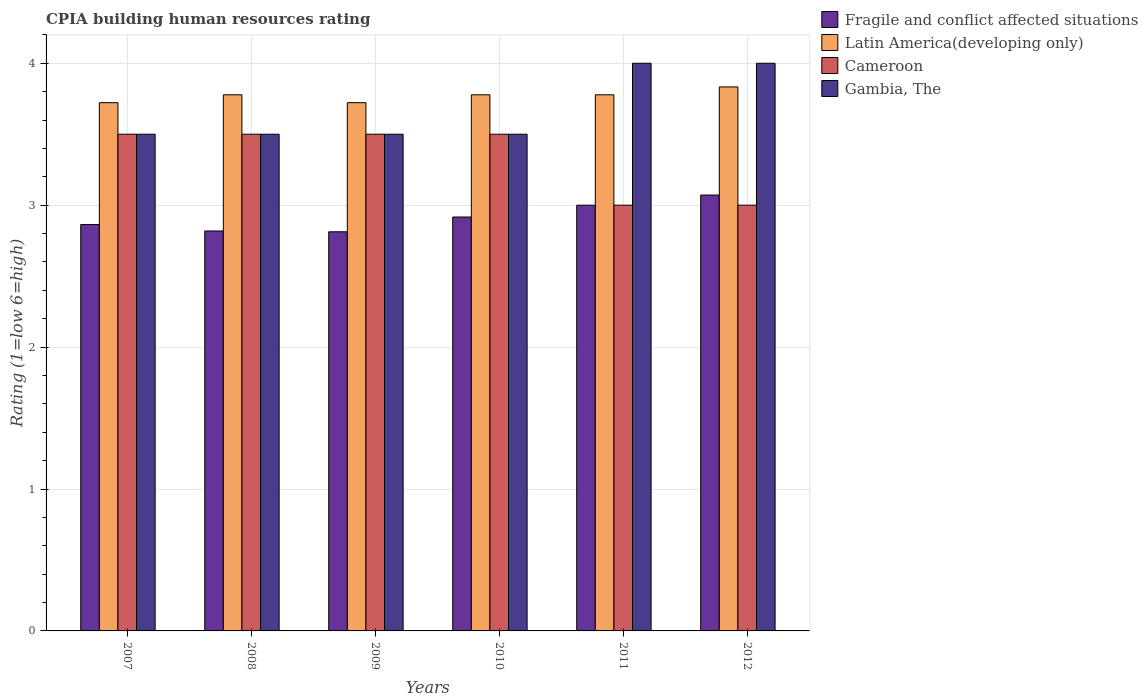How many groups of bars are there?
Provide a succinct answer. 6. Are the number of bars per tick equal to the number of legend labels?
Provide a succinct answer. Yes. What is the label of the 4th group of bars from the left?
Provide a short and direct response. 2010. In how many cases, is the number of bars for a given year not equal to the number of legend labels?
Provide a succinct answer. 0. What is the CPIA rating in Latin America(developing only) in 2007?
Provide a short and direct response. 3.72. Across all years, what is the maximum CPIA rating in Latin America(developing only)?
Provide a short and direct response. 3.83. Across all years, what is the minimum CPIA rating in Latin America(developing only)?
Your response must be concise. 3.72. What is the total CPIA rating in Cameroon in the graph?
Give a very brief answer. 20. What is the difference between the CPIA rating in Fragile and conflict affected situations in 2008 and that in 2012?
Your answer should be compact. -0.25. What is the difference between the CPIA rating in Latin America(developing only) in 2011 and the CPIA rating in Fragile and conflict affected situations in 2010?
Ensure brevity in your answer.  0.86. What is the average CPIA rating in Latin America(developing only) per year?
Your answer should be very brief. 3.77. In the year 2011, what is the difference between the CPIA rating in Gambia, The and CPIA rating in Cameroon?
Provide a short and direct response. 1. In how many years, is the CPIA rating in Latin America(developing only) greater than 0.6000000000000001?
Your answer should be compact. 6. What is the ratio of the CPIA rating in Cameroon in 2008 to that in 2010?
Make the answer very short. 1. Is the difference between the CPIA rating in Gambia, The in 2010 and 2012 greater than the difference between the CPIA rating in Cameroon in 2010 and 2012?
Make the answer very short. No. What is the difference between the highest and the lowest CPIA rating in Cameroon?
Offer a very short reply. 0.5. Is the sum of the CPIA rating in Cameroon in 2009 and 2010 greater than the maximum CPIA rating in Latin America(developing only) across all years?
Provide a short and direct response. Yes. What does the 3rd bar from the left in 2007 represents?
Your answer should be very brief. Cameroon. What does the 1st bar from the right in 2012 represents?
Make the answer very short. Gambia, The. How many bars are there?
Your answer should be compact. 24. Are all the bars in the graph horizontal?
Keep it short and to the point. No. What is the difference between two consecutive major ticks on the Y-axis?
Ensure brevity in your answer.  1. Are the values on the major ticks of Y-axis written in scientific E-notation?
Offer a very short reply. No. Does the graph contain any zero values?
Your answer should be very brief. No. What is the title of the graph?
Ensure brevity in your answer.  CPIA building human resources rating. What is the label or title of the X-axis?
Offer a very short reply. Years. What is the Rating (1=low 6=high) in Fragile and conflict affected situations in 2007?
Keep it short and to the point. 2.86. What is the Rating (1=low 6=high) in Latin America(developing only) in 2007?
Your response must be concise. 3.72. What is the Rating (1=low 6=high) of Fragile and conflict affected situations in 2008?
Offer a very short reply. 2.82. What is the Rating (1=low 6=high) in Latin America(developing only) in 2008?
Your response must be concise. 3.78. What is the Rating (1=low 6=high) in Cameroon in 2008?
Your answer should be compact. 3.5. What is the Rating (1=low 6=high) in Gambia, The in 2008?
Provide a short and direct response. 3.5. What is the Rating (1=low 6=high) of Fragile and conflict affected situations in 2009?
Offer a terse response. 2.81. What is the Rating (1=low 6=high) of Latin America(developing only) in 2009?
Provide a succinct answer. 3.72. What is the Rating (1=low 6=high) of Gambia, The in 2009?
Offer a very short reply. 3.5. What is the Rating (1=low 6=high) in Fragile and conflict affected situations in 2010?
Your response must be concise. 2.92. What is the Rating (1=low 6=high) in Latin America(developing only) in 2010?
Provide a short and direct response. 3.78. What is the Rating (1=low 6=high) of Fragile and conflict affected situations in 2011?
Keep it short and to the point. 3. What is the Rating (1=low 6=high) in Latin America(developing only) in 2011?
Offer a very short reply. 3.78. What is the Rating (1=low 6=high) in Fragile and conflict affected situations in 2012?
Your answer should be very brief. 3.07. What is the Rating (1=low 6=high) in Latin America(developing only) in 2012?
Offer a very short reply. 3.83. What is the Rating (1=low 6=high) in Cameroon in 2012?
Make the answer very short. 3. Across all years, what is the maximum Rating (1=low 6=high) of Fragile and conflict affected situations?
Your response must be concise. 3.07. Across all years, what is the maximum Rating (1=low 6=high) in Latin America(developing only)?
Offer a very short reply. 3.83. Across all years, what is the maximum Rating (1=low 6=high) in Gambia, The?
Keep it short and to the point. 4. Across all years, what is the minimum Rating (1=low 6=high) in Fragile and conflict affected situations?
Your answer should be compact. 2.81. Across all years, what is the minimum Rating (1=low 6=high) of Latin America(developing only)?
Offer a terse response. 3.72. Across all years, what is the minimum Rating (1=low 6=high) of Gambia, The?
Your answer should be very brief. 3.5. What is the total Rating (1=low 6=high) of Fragile and conflict affected situations in the graph?
Provide a short and direct response. 17.48. What is the total Rating (1=low 6=high) in Latin America(developing only) in the graph?
Offer a terse response. 22.61. What is the total Rating (1=low 6=high) in Cameroon in the graph?
Give a very brief answer. 20. What is the total Rating (1=low 6=high) of Gambia, The in the graph?
Your answer should be very brief. 22. What is the difference between the Rating (1=low 6=high) of Fragile and conflict affected situations in 2007 and that in 2008?
Ensure brevity in your answer.  0.05. What is the difference between the Rating (1=low 6=high) of Latin America(developing only) in 2007 and that in 2008?
Ensure brevity in your answer.  -0.06. What is the difference between the Rating (1=low 6=high) in Gambia, The in 2007 and that in 2008?
Your answer should be compact. 0. What is the difference between the Rating (1=low 6=high) of Fragile and conflict affected situations in 2007 and that in 2009?
Offer a very short reply. 0.05. What is the difference between the Rating (1=low 6=high) of Latin America(developing only) in 2007 and that in 2009?
Provide a succinct answer. 0. What is the difference between the Rating (1=low 6=high) in Cameroon in 2007 and that in 2009?
Offer a terse response. 0. What is the difference between the Rating (1=low 6=high) of Fragile and conflict affected situations in 2007 and that in 2010?
Offer a terse response. -0.05. What is the difference between the Rating (1=low 6=high) in Latin America(developing only) in 2007 and that in 2010?
Give a very brief answer. -0.06. What is the difference between the Rating (1=low 6=high) in Fragile and conflict affected situations in 2007 and that in 2011?
Provide a succinct answer. -0.14. What is the difference between the Rating (1=low 6=high) in Latin America(developing only) in 2007 and that in 2011?
Offer a very short reply. -0.06. What is the difference between the Rating (1=low 6=high) of Gambia, The in 2007 and that in 2011?
Keep it short and to the point. -0.5. What is the difference between the Rating (1=low 6=high) of Fragile and conflict affected situations in 2007 and that in 2012?
Give a very brief answer. -0.21. What is the difference between the Rating (1=low 6=high) of Latin America(developing only) in 2007 and that in 2012?
Offer a terse response. -0.11. What is the difference between the Rating (1=low 6=high) of Gambia, The in 2007 and that in 2012?
Your answer should be compact. -0.5. What is the difference between the Rating (1=low 6=high) in Fragile and conflict affected situations in 2008 and that in 2009?
Your answer should be very brief. 0.01. What is the difference between the Rating (1=low 6=high) of Latin America(developing only) in 2008 and that in 2009?
Offer a terse response. 0.06. What is the difference between the Rating (1=low 6=high) of Gambia, The in 2008 and that in 2009?
Your response must be concise. 0. What is the difference between the Rating (1=low 6=high) of Fragile and conflict affected situations in 2008 and that in 2010?
Offer a terse response. -0.1. What is the difference between the Rating (1=low 6=high) of Gambia, The in 2008 and that in 2010?
Your answer should be compact. 0. What is the difference between the Rating (1=low 6=high) of Fragile and conflict affected situations in 2008 and that in 2011?
Offer a terse response. -0.18. What is the difference between the Rating (1=low 6=high) in Latin America(developing only) in 2008 and that in 2011?
Keep it short and to the point. 0. What is the difference between the Rating (1=low 6=high) of Cameroon in 2008 and that in 2011?
Keep it short and to the point. 0.5. What is the difference between the Rating (1=low 6=high) of Gambia, The in 2008 and that in 2011?
Keep it short and to the point. -0.5. What is the difference between the Rating (1=low 6=high) of Fragile and conflict affected situations in 2008 and that in 2012?
Keep it short and to the point. -0.25. What is the difference between the Rating (1=low 6=high) in Latin America(developing only) in 2008 and that in 2012?
Give a very brief answer. -0.06. What is the difference between the Rating (1=low 6=high) in Cameroon in 2008 and that in 2012?
Your answer should be compact. 0.5. What is the difference between the Rating (1=low 6=high) of Gambia, The in 2008 and that in 2012?
Give a very brief answer. -0.5. What is the difference between the Rating (1=low 6=high) of Fragile and conflict affected situations in 2009 and that in 2010?
Give a very brief answer. -0.1. What is the difference between the Rating (1=low 6=high) in Latin America(developing only) in 2009 and that in 2010?
Your response must be concise. -0.06. What is the difference between the Rating (1=low 6=high) in Cameroon in 2009 and that in 2010?
Provide a short and direct response. 0. What is the difference between the Rating (1=low 6=high) of Fragile and conflict affected situations in 2009 and that in 2011?
Your response must be concise. -0.19. What is the difference between the Rating (1=low 6=high) in Latin America(developing only) in 2009 and that in 2011?
Provide a short and direct response. -0.06. What is the difference between the Rating (1=low 6=high) in Gambia, The in 2009 and that in 2011?
Keep it short and to the point. -0.5. What is the difference between the Rating (1=low 6=high) of Fragile and conflict affected situations in 2009 and that in 2012?
Your response must be concise. -0.26. What is the difference between the Rating (1=low 6=high) in Latin America(developing only) in 2009 and that in 2012?
Offer a terse response. -0.11. What is the difference between the Rating (1=low 6=high) of Gambia, The in 2009 and that in 2012?
Provide a succinct answer. -0.5. What is the difference between the Rating (1=low 6=high) in Fragile and conflict affected situations in 2010 and that in 2011?
Your answer should be compact. -0.08. What is the difference between the Rating (1=low 6=high) in Latin America(developing only) in 2010 and that in 2011?
Give a very brief answer. 0. What is the difference between the Rating (1=low 6=high) of Cameroon in 2010 and that in 2011?
Offer a terse response. 0.5. What is the difference between the Rating (1=low 6=high) in Fragile and conflict affected situations in 2010 and that in 2012?
Your answer should be compact. -0.15. What is the difference between the Rating (1=low 6=high) in Latin America(developing only) in 2010 and that in 2012?
Your response must be concise. -0.06. What is the difference between the Rating (1=low 6=high) of Cameroon in 2010 and that in 2012?
Offer a terse response. 0.5. What is the difference between the Rating (1=low 6=high) in Fragile and conflict affected situations in 2011 and that in 2012?
Give a very brief answer. -0.07. What is the difference between the Rating (1=low 6=high) in Latin America(developing only) in 2011 and that in 2012?
Ensure brevity in your answer.  -0.06. What is the difference between the Rating (1=low 6=high) of Cameroon in 2011 and that in 2012?
Your answer should be very brief. 0. What is the difference between the Rating (1=low 6=high) in Fragile and conflict affected situations in 2007 and the Rating (1=low 6=high) in Latin America(developing only) in 2008?
Provide a short and direct response. -0.91. What is the difference between the Rating (1=low 6=high) in Fragile and conflict affected situations in 2007 and the Rating (1=low 6=high) in Cameroon in 2008?
Provide a short and direct response. -0.64. What is the difference between the Rating (1=low 6=high) in Fragile and conflict affected situations in 2007 and the Rating (1=low 6=high) in Gambia, The in 2008?
Offer a terse response. -0.64. What is the difference between the Rating (1=low 6=high) of Latin America(developing only) in 2007 and the Rating (1=low 6=high) of Cameroon in 2008?
Your answer should be very brief. 0.22. What is the difference between the Rating (1=low 6=high) of Latin America(developing only) in 2007 and the Rating (1=low 6=high) of Gambia, The in 2008?
Provide a short and direct response. 0.22. What is the difference between the Rating (1=low 6=high) in Cameroon in 2007 and the Rating (1=low 6=high) in Gambia, The in 2008?
Your answer should be compact. 0. What is the difference between the Rating (1=low 6=high) of Fragile and conflict affected situations in 2007 and the Rating (1=low 6=high) of Latin America(developing only) in 2009?
Give a very brief answer. -0.86. What is the difference between the Rating (1=low 6=high) of Fragile and conflict affected situations in 2007 and the Rating (1=low 6=high) of Cameroon in 2009?
Provide a short and direct response. -0.64. What is the difference between the Rating (1=low 6=high) in Fragile and conflict affected situations in 2007 and the Rating (1=low 6=high) in Gambia, The in 2009?
Your answer should be very brief. -0.64. What is the difference between the Rating (1=low 6=high) in Latin America(developing only) in 2007 and the Rating (1=low 6=high) in Cameroon in 2009?
Offer a very short reply. 0.22. What is the difference between the Rating (1=low 6=high) in Latin America(developing only) in 2007 and the Rating (1=low 6=high) in Gambia, The in 2009?
Provide a succinct answer. 0.22. What is the difference between the Rating (1=low 6=high) in Cameroon in 2007 and the Rating (1=low 6=high) in Gambia, The in 2009?
Keep it short and to the point. 0. What is the difference between the Rating (1=low 6=high) of Fragile and conflict affected situations in 2007 and the Rating (1=low 6=high) of Latin America(developing only) in 2010?
Ensure brevity in your answer.  -0.91. What is the difference between the Rating (1=low 6=high) of Fragile and conflict affected situations in 2007 and the Rating (1=low 6=high) of Cameroon in 2010?
Provide a succinct answer. -0.64. What is the difference between the Rating (1=low 6=high) of Fragile and conflict affected situations in 2007 and the Rating (1=low 6=high) of Gambia, The in 2010?
Offer a terse response. -0.64. What is the difference between the Rating (1=low 6=high) in Latin America(developing only) in 2007 and the Rating (1=low 6=high) in Cameroon in 2010?
Provide a short and direct response. 0.22. What is the difference between the Rating (1=low 6=high) of Latin America(developing only) in 2007 and the Rating (1=low 6=high) of Gambia, The in 2010?
Keep it short and to the point. 0.22. What is the difference between the Rating (1=low 6=high) in Fragile and conflict affected situations in 2007 and the Rating (1=low 6=high) in Latin America(developing only) in 2011?
Provide a succinct answer. -0.91. What is the difference between the Rating (1=low 6=high) in Fragile and conflict affected situations in 2007 and the Rating (1=low 6=high) in Cameroon in 2011?
Provide a succinct answer. -0.14. What is the difference between the Rating (1=low 6=high) of Fragile and conflict affected situations in 2007 and the Rating (1=low 6=high) of Gambia, The in 2011?
Offer a very short reply. -1.14. What is the difference between the Rating (1=low 6=high) of Latin America(developing only) in 2007 and the Rating (1=low 6=high) of Cameroon in 2011?
Your answer should be compact. 0.72. What is the difference between the Rating (1=low 6=high) of Latin America(developing only) in 2007 and the Rating (1=low 6=high) of Gambia, The in 2011?
Offer a terse response. -0.28. What is the difference between the Rating (1=low 6=high) in Fragile and conflict affected situations in 2007 and the Rating (1=low 6=high) in Latin America(developing only) in 2012?
Your response must be concise. -0.97. What is the difference between the Rating (1=low 6=high) in Fragile and conflict affected situations in 2007 and the Rating (1=low 6=high) in Cameroon in 2012?
Offer a very short reply. -0.14. What is the difference between the Rating (1=low 6=high) of Fragile and conflict affected situations in 2007 and the Rating (1=low 6=high) of Gambia, The in 2012?
Offer a terse response. -1.14. What is the difference between the Rating (1=low 6=high) in Latin America(developing only) in 2007 and the Rating (1=low 6=high) in Cameroon in 2012?
Your response must be concise. 0.72. What is the difference between the Rating (1=low 6=high) in Latin America(developing only) in 2007 and the Rating (1=low 6=high) in Gambia, The in 2012?
Your response must be concise. -0.28. What is the difference between the Rating (1=low 6=high) in Cameroon in 2007 and the Rating (1=low 6=high) in Gambia, The in 2012?
Provide a succinct answer. -0.5. What is the difference between the Rating (1=low 6=high) in Fragile and conflict affected situations in 2008 and the Rating (1=low 6=high) in Latin America(developing only) in 2009?
Your answer should be compact. -0.9. What is the difference between the Rating (1=low 6=high) of Fragile and conflict affected situations in 2008 and the Rating (1=low 6=high) of Cameroon in 2009?
Your answer should be very brief. -0.68. What is the difference between the Rating (1=low 6=high) of Fragile and conflict affected situations in 2008 and the Rating (1=low 6=high) of Gambia, The in 2009?
Your answer should be very brief. -0.68. What is the difference between the Rating (1=low 6=high) of Latin America(developing only) in 2008 and the Rating (1=low 6=high) of Cameroon in 2009?
Your answer should be very brief. 0.28. What is the difference between the Rating (1=low 6=high) in Latin America(developing only) in 2008 and the Rating (1=low 6=high) in Gambia, The in 2009?
Offer a terse response. 0.28. What is the difference between the Rating (1=low 6=high) of Fragile and conflict affected situations in 2008 and the Rating (1=low 6=high) of Latin America(developing only) in 2010?
Keep it short and to the point. -0.96. What is the difference between the Rating (1=low 6=high) of Fragile and conflict affected situations in 2008 and the Rating (1=low 6=high) of Cameroon in 2010?
Ensure brevity in your answer.  -0.68. What is the difference between the Rating (1=low 6=high) in Fragile and conflict affected situations in 2008 and the Rating (1=low 6=high) in Gambia, The in 2010?
Offer a terse response. -0.68. What is the difference between the Rating (1=low 6=high) of Latin America(developing only) in 2008 and the Rating (1=low 6=high) of Cameroon in 2010?
Provide a succinct answer. 0.28. What is the difference between the Rating (1=low 6=high) of Latin America(developing only) in 2008 and the Rating (1=low 6=high) of Gambia, The in 2010?
Keep it short and to the point. 0.28. What is the difference between the Rating (1=low 6=high) of Cameroon in 2008 and the Rating (1=low 6=high) of Gambia, The in 2010?
Make the answer very short. 0. What is the difference between the Rating (1=low 6=high) of Fragile and conflict affected situations in 2008 and the Rating (1=low 6=high) of Latin America(developing only) in 2011?
Offer a terse response. -0.96. What is the difference between the Rating (1=low 6=high) of Fragile and conflict affected situations in 2008 and the Rating (1=low 6=high) of Cameroon in 2011?
Offer a very short reply. -0.18. What is the difference between the Rating (1=low 6=high) of Fragile and conflict affected situations in 2008 and the Rating (1=low 6=high) of Gambia, The in 2011?
Give a very brief answer. -1.18. What is the difference between the Rating (1=low 6=high) in Latin America(developing only) in 2008 and the Rating (1=low 6=high) in Gambia, The in 2011?
Give a very brief answer. -0.22. What is the difference between the Rating (1=low 6=high) of Fragile and conflict affected situations in 2008 and the Rating (1=low 6=high) of Latin America(developing only) in 2012?
Make the answer very short. -1.02. What is the difference between the Rating (1=low 6=high) of Fragile and conflict affected situations in 2008 and the Rating (1=low 6=high) of Cameroon in 2012?
Ensure brevity in your answer.  -0.18. What is the difference between the Rating (1=low 6=high) of Fragile and conflict affected situations in 2008 and the Rating (1=low 6=high) of Gambia, The in 2012?
Give a very brief answer. -1.18. What is the difference between the Rating (1=low 6=high) of Latin America(developing only) in 2008 and the Rating (1=low 6=high) of Cameroon in 2012?
Make the answer very short. 0.78. What is the difference between the Rating (1=low 6=high) in Latin America(developing only) in 2008 and the Rating (1=low 6=high) in Gambia, The in 2012?
Give a very brief answer. -0.22. What is the difference between the Rating (1=low 6=high) of Fragile and conflict affected situations in 2009 and the Rating (1=low 6=high) of Latin America(developing only) in 2010?
Provide a short and direct response. -0.97. What is the difference between the Rating (1=low 6=high) of Fragile and conflict affected situations in 2009 and the Rating (1=low 6=high) of Cameroon in 2010?
Your response must be concise. -0.69. What is the difference between the Rating (1=low 6=high) in Fragile and conflict affected situations in 2009 and the Rating (1=low 6=high) in Gambia, The in 2010?
Your answer should be very brief. -0.69. What is the difference between the Rating (1=low 6=high) in Latin America(developing only) in 2009 and the Rating (1=low 6=high) in Cameroon in 2010?
Your answer should be compact. 0.22. What is the difference between the Rating (1=low 6=high) of Latin America(developing only) in 2009 and the Rating (1=low 6=high) of Gambia, The in 2010?
Your answer should be very brief. 0.22. What is the difference between the Rating (1=low 6=high) in Cameroon in 2009 and the Rating (1=low 6=high) in Gambia, The in 2010?
Offer a terse response. 0. What is the difference between the Rating (1=low 6=high) in Fragile and conflict affected situations in 2009 and the Rating (1=low 6=high) in Latin America(developing only) in 2011?
Your answer should be very brief. -0.97. What is the difference between the Rating (1=low 6=high) of Fragile and conflict affected situations in 2009 and the Rating (1=low 6=high) of Cameroon in 2011?
Offer a very short reply. -0.19. What is the difference between the Rating (1=low 6=high) of Fragile and conflict affected situations in 2009 and the Rating (1=low 6=high) of Gambia, The in 2011?
Offer a terse response. -1.19. What is the difference between the Rating (1=low 6=high) of Latin America(developing only) in 2009 and the Rating (1=low 6=high) of Cameroon in 2011?
Offer a very short reply. 0.72. What is the difference between the Rating (1=low 6=high) in Latin America(developing only) in 2009 and the Rating (1=low 6=high) in Gambia, The in 2011?
Your answer should be compact. -0.28. What is the difference between the Rating (1=low 6=high) of Cameroon in 2009 and the Rating (1=low 6=high) of Gambia, The in 2011?
Offer a terse response. -0.5. What is the difference between the Rating (1=low 6=high) of Fragile and conflict affected situations in 2009 and the Rating (1=low 6=high) of Latin America(developing only) in 2012?
Ensure brevity in your answer.  -1.02. What is the difference between the Rating (1=low 6=high) in Fragile and conflict affected situations in 2009 and the Rating (1=low 6=high) in Cameroon in 2012?
Provide a short and direct response. -0.19. What is the difference between the Rating (1=low 6=high) of Fragile and conflict affected situations in 2009 and the Rating (1=low 6=high) of Gambia, The in 2012?
Make the answer very short. -1.19. What is the difference between the Rating (1=low 6=high) of Latin America(developing only) in 2009 and the Rating (1=low 6=high) of Cameroon in 2012?
Your answer should be compact. 0.72. What is the difference between the Rating (1=low 6=high) in Latin America(developing only) in 2009 and the Rating (1=low 6=high) in Gambia, The in 2012?
Ensure brevity in your answer.  -0.28. What is the difference between the Rating (1=low 6=high) in Fragile and conflict affected situations in 2010 and the Rating (1=low 6=high) in Latin America(developing only) in 2011?
Your answer should be very brief. -0.86. What is the difference between the Rating (1=low 6=high) in Fragile and conflict affected situations in 2010 and the Rating (1=low 6=high) in Cameroon in 2011?
Provide a succinct answer. -0.08. What is the difference between the Rating (1=low 6=high) in Fragile and conflict affected situations in 2010 and the Rating (1=low 6=high) in Gambia, The in 2011?
Offer a very short reply. -1.08. What is the difference between the Rating (1=low 6=high) in Latin America(developing only) in 2010 and the Rating (1=low 6=high) in Cameroon in 2011?
Offer a very short reply. 0.78. What is the difference between the Rating (1=low 6=high) in Latin America(developing only) in 2010 and the Rating (1=low 6=high) in Gambia, The in 2011?
Ensure brevity in your answer.  -0.22. What is the difference between the Rating (1=low 6=high) of Cameroon in 2010 and the Rating (1=low 6=high) of Gambia, The in 2011?
Provide a short and direct response. -0.5. What is the difference between the Rating (1=low 6=high) of Fragile and conflict affected situations in 2010 and the Rating (1=low 6=high) of Latin America(developing only) in 2012?
Your response must be concise. -0.92. What is the difference between the Rating (1=low 6=high) in Fragile and conflict affected situations in 2010 and the Rating (1=low 6=high) in Cameroon in 2012?
Your answer should be very brief. -0.08. What is the difference between the Rating (1=low 6=high) of Fragile and conflict affected situations in 2010 and the Rating (1=low 6=high) of Gambia, The in 2012?
Your response must be concise. -1.08. What is the difference between the Rating (1=low 6=high) of Latin America(developing only) in 2010 and the Rating (1=low 6=high) of Cameroon in 2012?
Your answer should be very brief. 0.78. What is the difference between the Rating (1=low 6=high) in Latin America(developing only) in 2010 and the Rating (1=low 6=high) in Gambia, The in 2012?
Ensure brevity in your answer.  -0.22. What is the difference between the Rating (1=low 6=high) in Fragile and conflict affected situations in 2011 and the Rating (1=low 6=high) in Latin America(developing only) in 2012?
Keep it short and to the point. -0.83. What is the difference between the Rating (1=low 6=high) in Fragile and conflict affected situations in 2011 and the Rating (1=low 6=high) in Cameroon in 2012?
Ensure brevity in your answer.  0. What is the difference between the Rating (1=low 6=high) of Fragile and conflict affected situations in 2011 and the Rating (1=low 6=high) of Gambia, The in 2012?
Ensure brevity in your answer.  -1. What is the difference between the Rating (1=low 6=high) of Latin America(developing only) in 2011 and the Rating (1=low 6=high) of Cameroon in 2012?
Your response must be concise. 0.78. What is the difference between the Rating (1=low 6=high) in Latin America(developing only) in 2011 and the Rating (1=low 6=high) in Gambia, The in 2012?
Provide a short and direct response. -0.22. What is the average Rating (1=low 6=high) of Fragile and conflict affected situations per year?
Make the answer very short. 2.91. What is the average Rating (1=low 6=high) of Latin America(developing only) per year?
Your answer should be very brief. 3.77. What is the average Rating (1=low 6=high) of Cameroon per year?
Provide a succinct answer. 3.33. What is the average Rating (1=low 6=high) of Gambia, The per year?
Make the answer very short. 3.67. In the year 2007, what is the difference between the Rating (1=low 6=high) in Fragile and conflict affected situations and Rating (1=low 6=high) in Latin America(developing only)?
Keep it short and to the point. -0.86. In the year 2007, what is the difference between the Rating (1=low 6=high) of Fragile and conflict affected situations and Rating (1=low 6=high) of Cameroon?
Provide a succinct answer. -0.64. In the year 2007, what is the difference between the Rating (1=low 6=high) of Fragile and conflict affected situations and Rating (1=low 6=high) of Gambia, The?
Your answer should be compact. -0.64. In the year 2007, what is the difference between the Rating (1=low 6=high) in Latin America(developing only) and Rating (1=low 6=high) in Cameroon?
Provide a succinct answer. 0.22. In the year 2007, what is the difference between the Rating (1=low 6=high) in Latin America(developing only) and Rating (1=low 6=high) in Gambia, The?
Your response must be concise. 0.22. In the year 2007, what is the difference between the Rating (1=low 6=high) in Cameroon and Rating (1=low 6=high) in Gambia, The?
Your answer should be compact. 0. In the year 2008, what is the difference between the Rating (1=low 6=high) in Fragile and conflict affected situations and Rating (1=low 6=high) in Latin America(developing only)?
Make the answer very short. -0.96. In the year 2008, what is the difference between the Rating (1=low 6=high) in Fragile and conflict affected situations and Rating (1=low 6=high) in Cameroon?
Offer a very short reply. -0.68. In the year 2008, what is the difference between the Rating (1=low 6=high) in Fragile and conflict affected situations and Rating (1=low 6=high) in Gambia, The?
Your answer should be compact. -0.68. In the year 2008, what is the difference between the Rating (1=low 6=high) in Latin America(developing only) and Rating (1=low 6=high) in Cameroon?
Offer a very short reply. 0.28. In the year 2008, what is the difference between the Rating (1=low 6=high) in Latin America(developing only) and Rating (1=low 6=high) in Gambia, The?
Keep it short and to the point. 0.28. In the year 2008, what is the difference between the Rating (1=low 6=high) of Cameroon and Rating (1=low 6=high) of Gambia, The?
Your answer should be compact. 0. In the year 2009, what is the difference between the Rating (1=low 6=high) in Fragile and conflict affected situations and Rating (1=low 6=high) in Latin America(developing only)?
Your response must be concise. -0.91. In the year 2009, what is the difference between the Rating (1=low 6=high) of Fragile and conflict affected situations and Rating (1=low 6=high) of Cameroon?
Ensure brevity in your answer.  -0.69. In the year 2009, what is the difference between the Rating (1=low 6=high) in Fragile and conflict affected situations and Rating (1=low 6=high) in Gambia, The?
Your response must be concise. -0.69. In the year 2009, what is the difference between the Rating (1=low 6=high) of Latin America(developing only) and Rating (1=low 6=high) of Cameroon?
Your response must be concise. 0.22. In the year 2009, what is the difference between the Rating (1=low 6=high) of Latin America(developing only) and Rating (1=low 6=high) of Gambia, The?
Keep it short and to the point. 0.22. In the year 2010, what is the difference between the Rating (1=low 6=high) in Fragile and conflict affected situations and Rating (1=low 6=high) in Latin America(developing only)?
Provide a succinct answer. -0.86. In the year 2010, what is the difference between the Rating (1=low 6=high) in Fragile and conflict affected situations and Rating (1=low 6=high) in Cameroon?
Your response must be concise. -0.58. In the year 2010, what is the difference between the Rating (1=low 6=high) in Fragile and conflict affected situations and Rating (1=low 6=high) in Gambia, The?
Give a very brief answer. -0.58. In the year 2010, what is the difference between the Rating (1=low 6=high) of Latin America(developing only) and Rating (1=low 6=high) of Cameroon?
Give a very brief answer. 0.28. In the year 2010, what is the difference between the Rating (1=low 6=high) of Latin America(developing only) and Rating (1=low 6=high) of Gambia, The?
Your response must be concise. 0.28. In the year 2010, what is the difference between the Rating (1=low 6=high) in Cameroon and Rating (1=low 6=high) in Gambia, The?
Keep it short and to the point. 0. In the year 2011, what is the difference between the Rating (1=low 6=high) of Fragile and conflict affected situations and Rating (1=low 6=high) of Latin America(developing only)?
Offer a very short reply. -0.78. In the year 2011, what is the difference between the Rating (1=low 6=high) of Fragile and conflict affected situations and Rating (1=low 6=high) of Cameroon?
Give a very brief answer. 0. In the year 2011, what is the difference between the Rating (1=low 6=high) in Latin America(developing only) and Rating (1=low 6=high) in Gambia, The?
Make the answer very short. -0.22. In the year 2011, what is the difference between the Rating (1=low 6=high) in Cameroon and Rating (1=low 6=high) in Gambia, The?
Make the answer very short. -1. In the year 2012, what is the difference between the Rating (1=low 6=high) in Fragile and conflict affected situations and Rating (1=low 6=high) in Latin America(developing only)?
Your answer should be very brief. -0.76. In the year 2012, what is the difference between the Rating (1=low 6=high) of Fragile and conflict affected situations and Rating (1=low 6=high) of Cameroon?
Offer a very short reply. 0.07. In the year 2012, what is the difference between the Rating (1=low 6=high) of Fragile and conflict affected situations and Rating (1=low 6=high) of Gambia, The?
Your response must be concise. -0.93. In the year 2012, what is the difference between the Rating (1=low 6=high) of Latin America(developing only) and Rating (1=low 6=high) of Cameroon?
Your answer should be very brief. 0.83. In the year 2012, what is the difference between the Rating (1=low 6=high) in Latin America(developing only) and Rating (1=low 6=high) in Gambia, The?
Ensure brevity in your answer.  -0.17. In the year 2012, what is the difference between the Rating (1=low 6=high) of Cameroon and Rating (1=low 6=high) of Gambia, The?
Offer a terse response. -1. What is the ratio of the Rating (1=low 6=high) in Fragile and conflict affected situations in 2007 to that in 2008?
Give a very brief answer. 1.02. What is the ratio of the Rating (1=low 6=high) of Latin America(developing only) in 2007 to that in 2008?
Ensure brevity in your answer.  0.99. What is the ratio of the Rating (1=low 6=high) of Cameroon in 2007 to that in 2008?
Ensure brevity in your answer.  1. What is the ratio of the Rating (1=low 6=high) of Fragile and conflict affected situations in 2007 to that in 2009?
Your answer should be very brief. 1.02. What is the ratio of the Rating (1=low 6=high) of Latin America(developing only) in 2007 to that in 2009?
Offer a very short reply. 1. What is the ratio of the Rating (1=low 6=high) in Fragile and conflict affected situations in 2007 to that in 2010?
Keep it short and to the point. 0.98. What is the ratio of the Rating (1=low 6=high) in Fragile and conflict affected situations in 2007 to that in 2011?
Keep it short and to the point. 0.95. What is the ratio of the Rating (1=low 6=high) in Latin America(developing only) in 2007 to that in 2011?
Your response must be concise. 0.99. What is the ratio of the Rating (1=low 6=high) in Cameroon in 2007 to that in 2011?
Give a very brief answer. 1.17. What is the ratio of the Rating (1=low 6=high) of Fragile and conflict affected situations in 2007 to that in 2012?
Your answer should be very brief. 0.93. What is the ratio of the Rating (1=low 6=high) in Latin America(developing only) in 2007 to that in 2012?
Give a very brief answer. 0.97. What is the ratio of the Rating (1=low 6=high) in Fragile and conflict affected situations in 2008 to that in 2009?
Offer a terse response. 1. What is the ratio of the Rating (1=low 6=high) of Latin America(developing only) in 2008 to that in 2009?
Keep it short and to the point. 1.01. What is the ratio of the Rating (1=low 6=high) of Cameroon in 2008 to that in 2009?
Provide a succinct answer. 1. What is the ratio of the Rating (1=low 6=high) in Gambia, The in 2008 to that in 2009?
Provide a succinct answer. 1. What is the ratio of the Rating (1=low 6=high) of Fragile and conflict affected situations in 2008 to that in 2010?
Provide a succinct answer. 0.97. What is the ratio of the Rating (1=low 6=high) of Latin America(developing only) in 2008 to that in 2010?
Give a very brief answer. 1. What is the ratio of the Rating (1=low 6=high) of Gambia, The in 2008 to that in 2010?
Offer a terse response. 1. What is the ratio of the Rating (1=low 6=high) in Fragile and conflict affected situations in 2008 to that in 2011?
Offer a terse response. 0.94. What is the ratio of the Rating (1=low 6=high) in Latin America(developing only) in 2008 to that in 2011?
Your response must be concise. 1. What is the ratio of the Rating (1=low 6=high) of Cameroon in 2008 to that in 2011?
Your answer should be compact. 1.17. What is the ratio of the Rating (1=low 6=high) in Fragile and conflict affected situations in 2008 to that in 2012?
Give a very brief answer. 0.92. What is the ratio of the Rating (1=low 6=high) of Latin America(developing only) in 2008 to that in 2012?
Give a very brief answer. 0.99. What is the ratio of the Rating (1=low 6=high) in Cameroon in 2008 to that in 2012?
Offer a terse response. 1.17. What is the ratio of the Rating (1=low 6=high) of Gambia, The in 2008 to that in 2012?
Your answer should be very brief. 0.88. What is the ratio of the Rating (1=low 6=high) in Fragile and conflict affected situations in 2009 to that in 2011?
Ensure brevity in your answer.  0.94. What is the ratio of the Rating (1=low 6=high) in Latin America(developing only) in 2009 to that in 2011?
Provide a short and direct response. 0.99. What is the ratio of the Rating (1=low 6=high) of Fragile and conflict affected situations in 2009 to that in 2012?
Give a very brief answer. 0.92. What is the ratio of the Rating (1=low 6=high) in Gambia, The in 2009 to that in 2012?
Provide a succinct answer. 0.88. What is the ratio of the Rating (1=low 6=high) in Fragile and conflict affected situations in 2010 to that in 2011?
Your answer should be compact. 0.97. What is the ratio of the Rating (1=low 6=high) in Gambia, The in 2010 to that in 2011?
Ensure brevity in your answer.  0.88. What is the ratio of the Rating (1=low 6=high) in Fragile and conflict affected situations in 2010 to that in 2012?
Your answer should be compact. 0.95. What is the ratio of the Rating (1=low 6=high) of Latin America(developing only) in 2010 to that in 2012?
Your answer should be very brief. 0.99. What is the ratio of the Rating (1=low 6=high) in Cameroon in 2010 to that in 2012?
Offer a very short reply. 1.17. What is the ratio of the Rating (1=low 6=high) in Fragile and conflict affected situations in 2011 to that in 2012?
Keep it short and to the point. 0.98. What is the ratio of the Rating (1=low 6=high) in Latin America(developing only) in 2011 to that in 2012?
Provide a short and direct response. 0.99. What is the ratio of the Rating (1=low 6=high) in Cameroon in 2011 to that in 2012?
Offer a very short reply. 1. What is the difference between the highest and the second highest Rating (1=low 6=high) in Fragile and conflict affected situations?
Ensure brevity in your answer.  0.07. What is the difference between the highest and the second highest Rating (1=low 6=high) in Latin America(developing only)?
Offer a very short reply. 0.06. What is the difference between the highest and the lowest Rating (1=low 6=high) in Fragile and conflict affected situations?
Give a very brief answer. 0.26. 